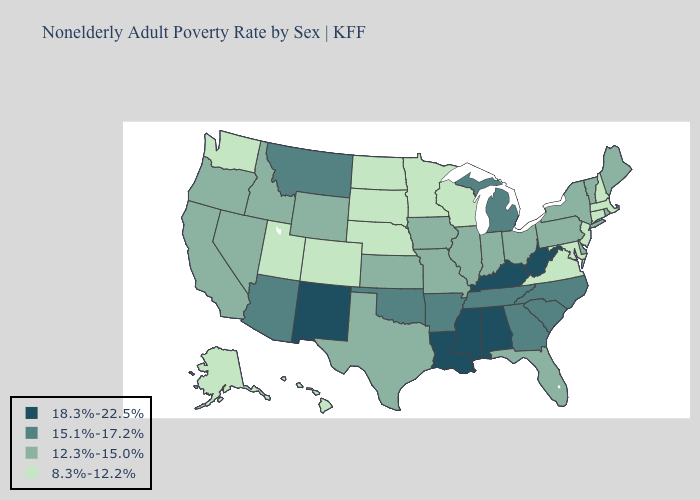What is the value of Tennessee?
Quick response, please. 15.1%-17.2%. Name the states that have a value in the range 12.3%-15.0%?
Give a very brief answer. California, Delaware, Florida, Idaho, Illinois, Indiana, Iowa, Kansas, Maine, Missouri, Nevada, New York, Ohio, Oregon, Pennsylvania, Rhode Island, Texas, Vermont, Wyoming. What is the highest value in the South ?
Be succinct. 18.3%-22.5%. Name the states that have a value in the range 12.3%-15.0%?
Quick response, please. California, Delaware, Florida, Idaho, Illinois, Indiana, Iowa, Kansas, Maine, Missouri, Nevada, New York, Ohio, Oregon, Pennsylvania, Rhode Island, Texas, Vermont, Wyoming. Does Vermont have the lowest value in the Northeast?
Write a very short answer. No. What is the value of Missouri?
Short answer required. 12.3%-15.0%. What is the highest value in the USA?
Short answer required. 18.3%-22.5%. Name the states that have a value in the range 15.1%-17.2%?
Concise answer only. Arizona, Arkansas, Georgia, Michigan, Montana, North Carolina, Oklahoma, South Carolina, Tennessee. Does Missouri have a lower value than New Jersey?
Quick response, please. No. What is the lowest value in the USA?
Give a very brief answer. 8.3%-12.2%. What is the lowest value in the West?
Keep it brief. 8.3%-12.2%. Does Mississippi have the highest value in the South?
Write a very short answer. Yes. How many symbols are there in the legend?
Quick response, please. 4. What is the value of Mississippi?
Short answer required. 18.3%-22.5%. What is the highest value in states that border Delaware?
Keep it brief. 12.3%-15.0%. 